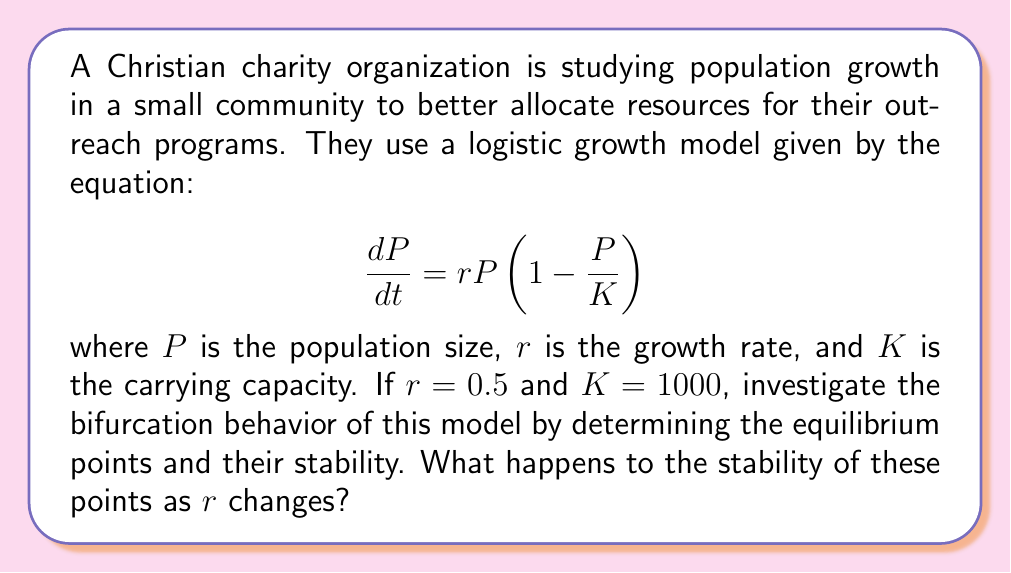Teach me how to tackle this problem. 1. Find the equilibrium points:
   Set $\frac{dP}{dt} = 0$:
   $$0 = rP(1 - \frac{P}{K})$$
   $$0 = 0.5P(1 - \frac{P}{1000})$$
   
   Solving this equation:
   a) $P = 0$
   b) $P = 1000$

2. Analyze stability:
   Calculate the derivative of $\frac{dP}{dt}$ with respect to $P$:
   $$\frac{d}{dP}(\frac{dP}{dt}) = r(1 - \frac{2P}{K}) = 0.5(1 - \frac{2P}{1000})$$

3. Evaluate stability at equilibrium points:
   a) At $P = 0$:
      $$0.5(1 - \frac{2(0)}{1000}) = 0.5 > 0$$
      This is unstable.
   
   b) At $P = 1000$:
      $$0.5(1 - \frac{2(1000)}{1000}) = -0.5 < 0$$
      This is stable.

4. Bifurcation analysis:
   The stability of these points doesn't change as $r$ varies, as long as $r > 0$. 
   - $P = 0$ remains unstable for all positive $r$.
   - $P = K$ (1000 in this case) remains stable for all positive $r$.

   However, if $r$ becomes negative, a transcritical bifurcation occurs:
   - $P = 0$ becomes stable
   - $P = K$ becomes unstable

   The bifurcation point is at $r = 0$.
Answer: Two equilibrium points: $P = 0$ (unstable) and $P = 1000$ (stable). Transcritical bifurcation at $r = 0$. 